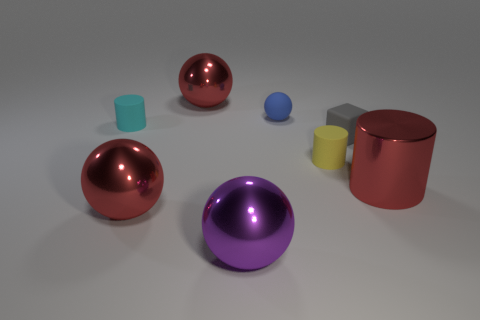Are the red object that is to the right of the purple thing and the purple ball made of the same material?
Offer a terse response. Yes. There is a large red shiny object that is in front of the red shiny thing on the right side of the purple thing; are there any red metal spheres that are behind it?
Offer a terse response. Yes. Is the shape of the big metallic object behind the yellow matte cylinder the same as  the blue object?
Provide a succinct answer. Yes. What shape is the large red thing behind the red shiny thing that is to the right of the yellow cylinder?
Offer a very short reply. Sphere. There is a metal ball that is right of the big metallic object that is behind the red thing right of the large purple sphere; what size is it?
Your answer should be compact. Large. There is a small object that is the same shape as the big purple thing; what color is it?
Give a very brief answer. Blue. Do the cyan rubber cylinder and the yellow object have the same size?
Give a very brief answer. Yes. There is a tiny blue sphere left of the gray matte object; what is it made of?
Offer a terse response. Rubber. How many other objects are the same shape as the tiny gray rubber object?
Give a very brief answer. 0. Is the big purple thing the same shape as the small blue matte thing?
Your answer should be very brief. Yes. 